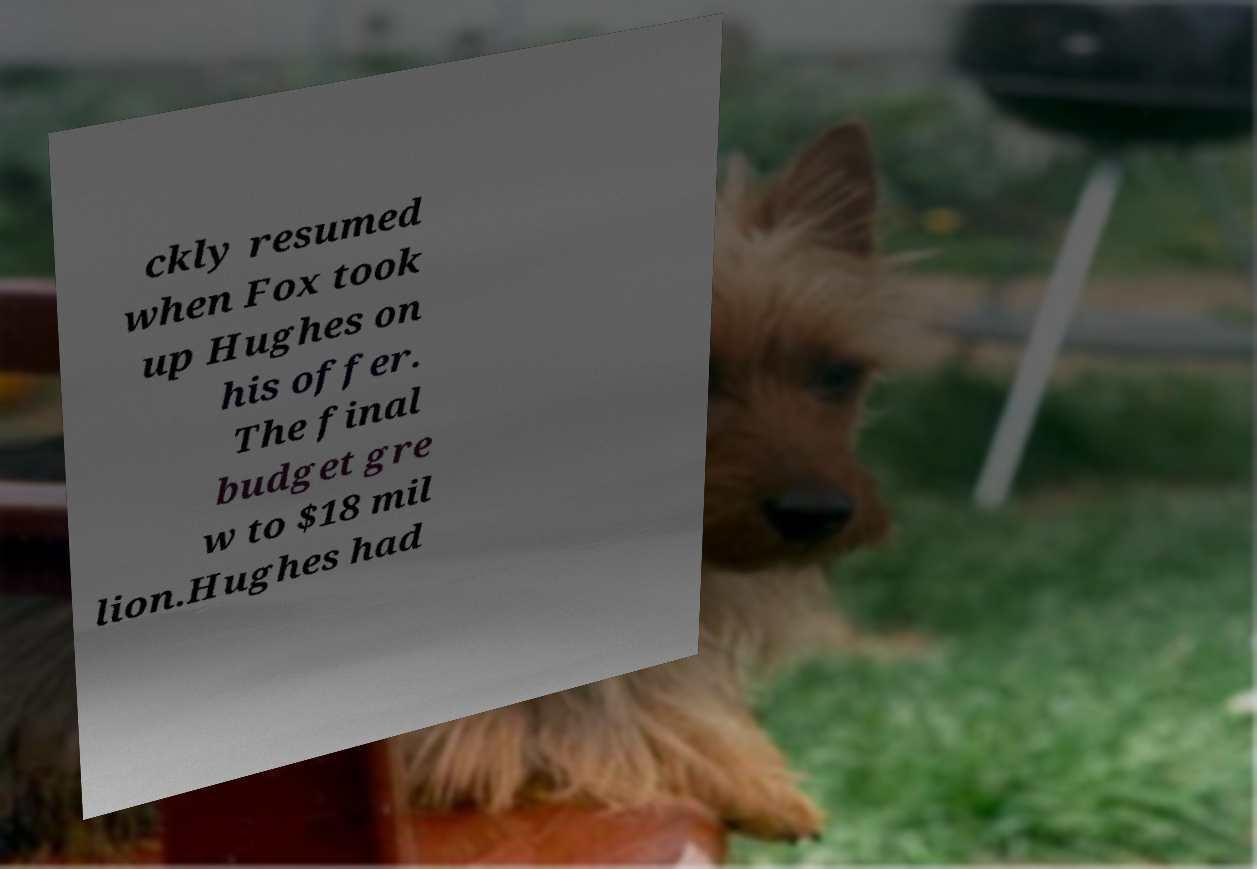What messages or text are displayed in this image? I need them in a readable, typed format. ckly resumed when Fox took up Hughes on his offer. The final budget gre w to $18 mil lion.Hughes had 